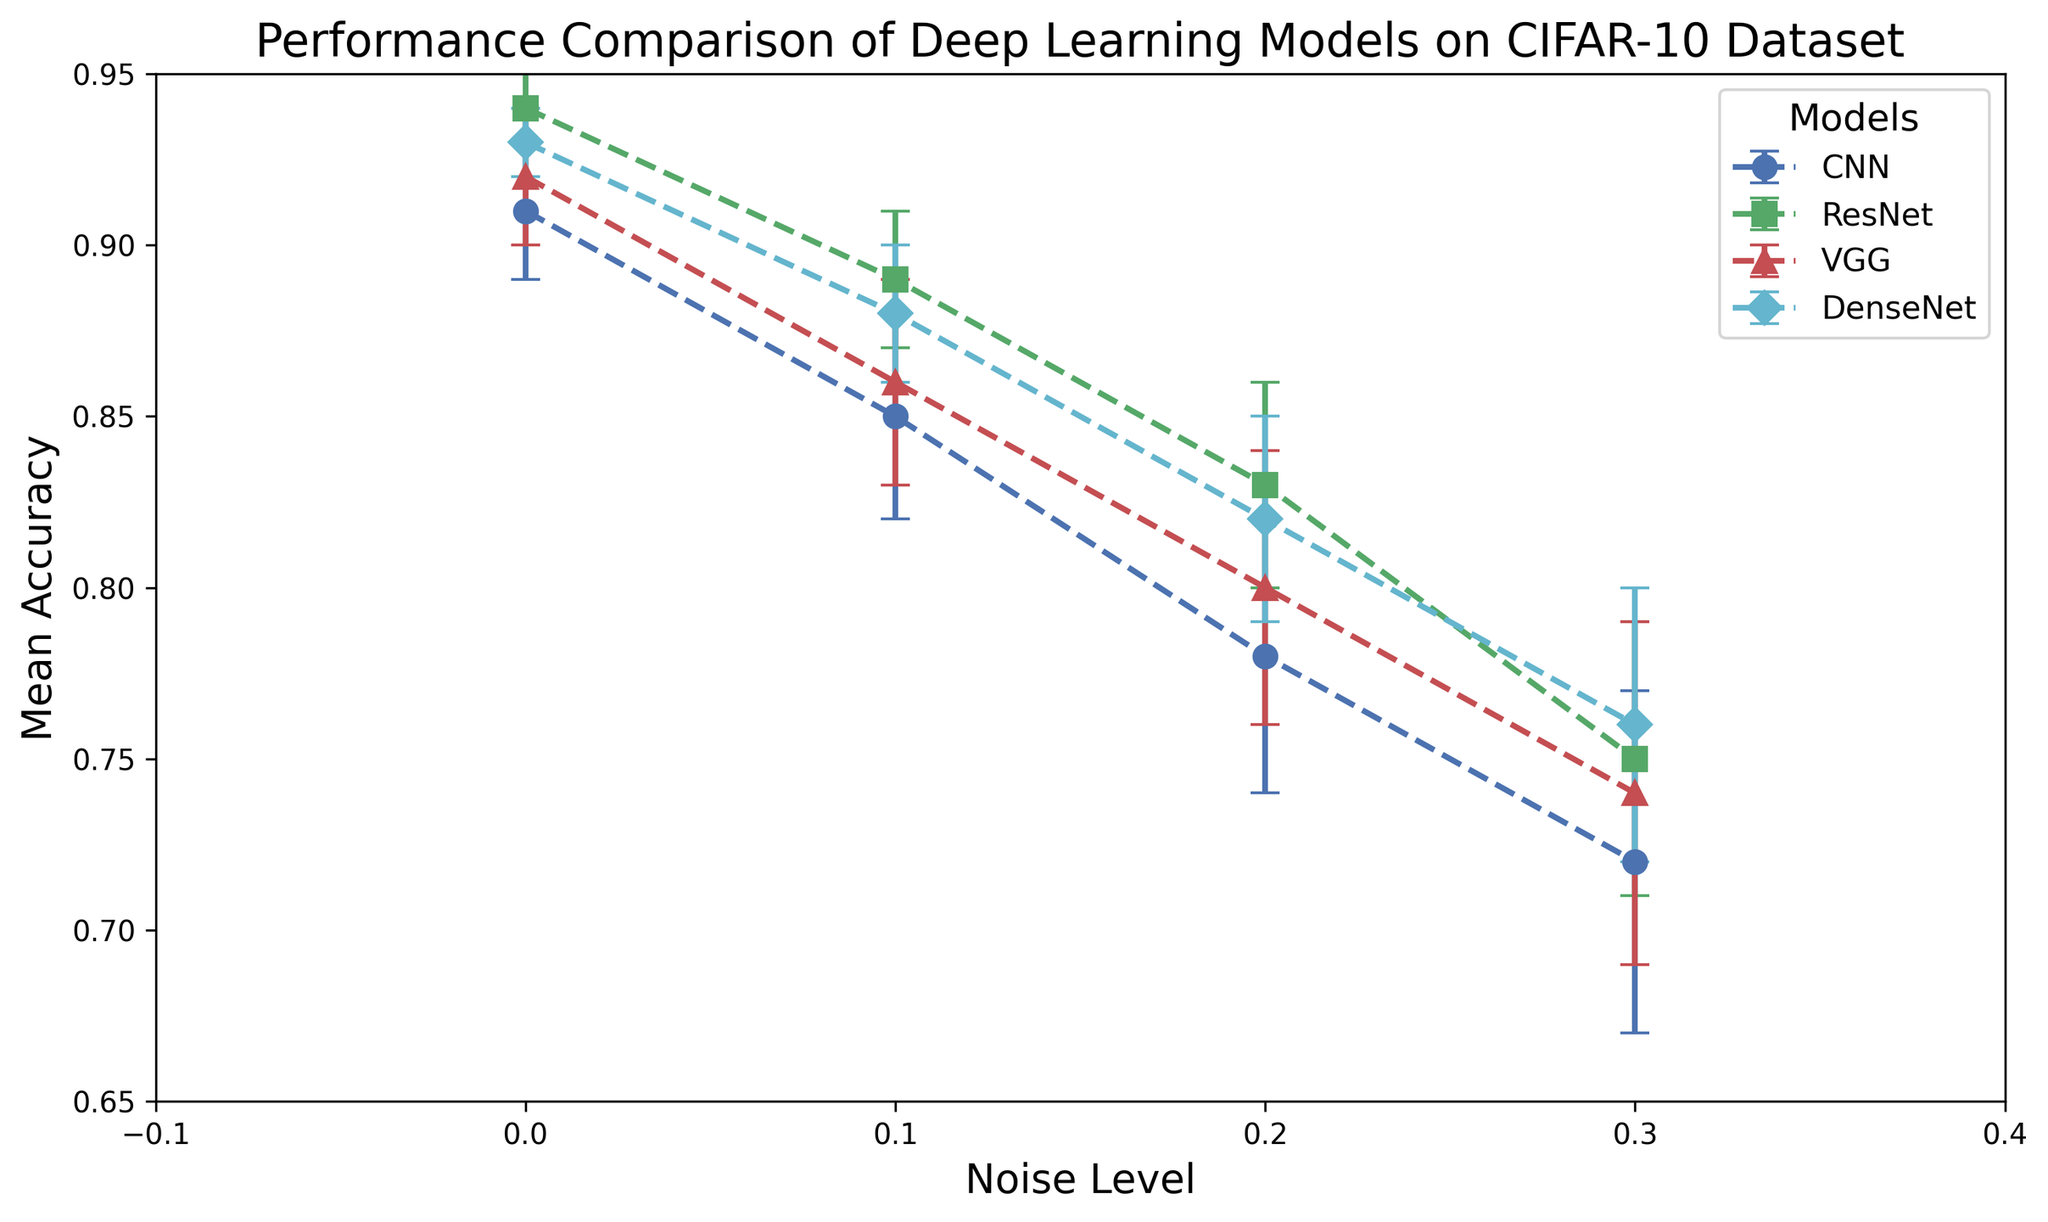What is the performance difference between CNN and ResNet models at a noise level of 0.3? First, identify the mean accuracies of CNN and ResNet models from the figure at a 0.3 noise level. The mean accuracy for CNN is 0.72, and for ResNet, it is 0.75. The performance difference is found by subtracting the accuracy of CNN from ResNet (0.75 - 0.72).
Answer: 0.03 Which model has the highest mean accuracy at a noise level of 0.2? From the figure, identify the mean accuracies of each model at a noise level of 0.2. CNN has 0.78, ResNet has 0.83, VGG has 0.80, and DenseNet has 0.82. The model with the highest mean accuracy is ResNet with 0.83.
Answer: ResNet What is the average mean accuracy of the DenseNet model across all noise levels? First, sum the mean accuracies of the DenseNet model at all noise levels: 0.93 (0.0 noise), 0.88 (0.1 noise), 0.82 (0.2 noise), and 0.76 (0.3 noise). The total is 0.93 + 0.88 + 0.82 + 0.76 = 3.39. Then, divide by the number of noise levels, which is 4. So, 3.39 / 4 = 0.8475.
Answer: 0.8475 Between VGG and ResNet, which model shows a greater decline in mean accuracy from noise level 0.0 to 0.3? First, calculate the decline for VGG (0.92 - 0.74) = 0.18. Next, calculate the decline for ResNet (0.94 - 0.75) = 0.19. The model with the larger decline is ResNet.
Answer: ResNet How does the mean accuracy of CNN at noise level 0.1 compare to the mean accuracy of VGG at the same noise level? From the figure, the mean accuracy of CNN at noise level 0.1 is 0.85, and for VGG it is 0.86. Comparing these values, VGG has a slightly higher mean accuracy than CNN at 0.1 noise level.
Answer: VGG Which model maintains the highest mean accuracy consistently across different noise levels? From the figure, observe the mean accuracies of each model across all noise levels. ResNet has mean accuracies of 0.94 (0.0 noise), 0.89 (0.1 noise), 0.83 (0.2 noise), and 0.75 (0.3 noise). Comparing with other models, ResNet maintains the highest mean accuracy consistently.
Answer: ResNet What is the standard deviation range of the CNN model at noise level 0.3? From the figure, the mean accuracy of CNN at noise level 0.3 is 0.72 with a standard deviation of 0.05. The standard deviation range is (0.72 - 0.05) to (0.72 + 0.05), which is 0.67 to 0.77.
Answer: 0.67 to 0.77 Between the models, which one shows the least variation in mean accuracy as the noise level increases? Identify the standard deviations for each model across all noise levels. The model with the lowest range in standard deviations shows the least variation. ResNet's standard deviations are 0.01, 0.02, 0.03, and 0.04, which are the smallest values amongst the models. This indicates ResNet has the least variation in mean accuracy.
Answer: ResNet 